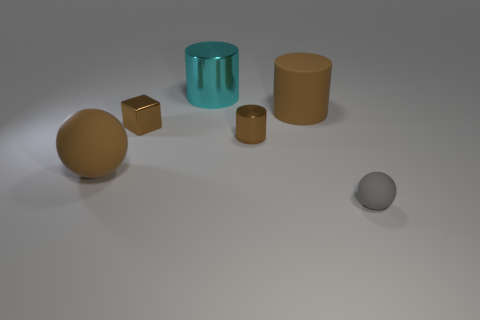What number of shiny objects are either tiny blocks or brown cylinders?
Your response must be concise. 2. What size is the gray thing that is to the right of the cyan thing?
Provide a succinct answer. Small. There is a block that is the same material as the big cyan cylinder; what size is it?
Give a very brief answer. Small. How many metallic cubes are the same color as the big matte ball?
Keep it short and to the point. 1. Are any cyan shiny things visible?
Ensure brevity in your answer.  Yes. There is a gray rubber thing; is its shape the same as the big brown matte thing left of the large cyan thing?
Your answer should be compact. Yes. There is a ball behind the sphere to the right of the sphere that is left of the small brown block; what color is it?
Give a very brief answer. Brown. Are there any cylinders right of the big cyan metal cylinder?
Give a very brief answer. Yes. There is a ball that is the same color as the tiny metal block; what size is it?
Give a very brief answer. Large. Is there a large gray object that has the same material as the tiny ball?
Provide a succinct answer. No. 